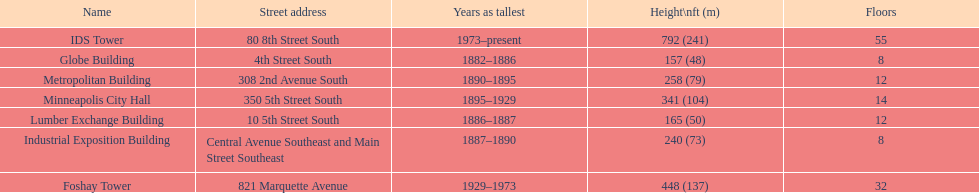How tall is it to the top of the ids tower in feet? 792. 